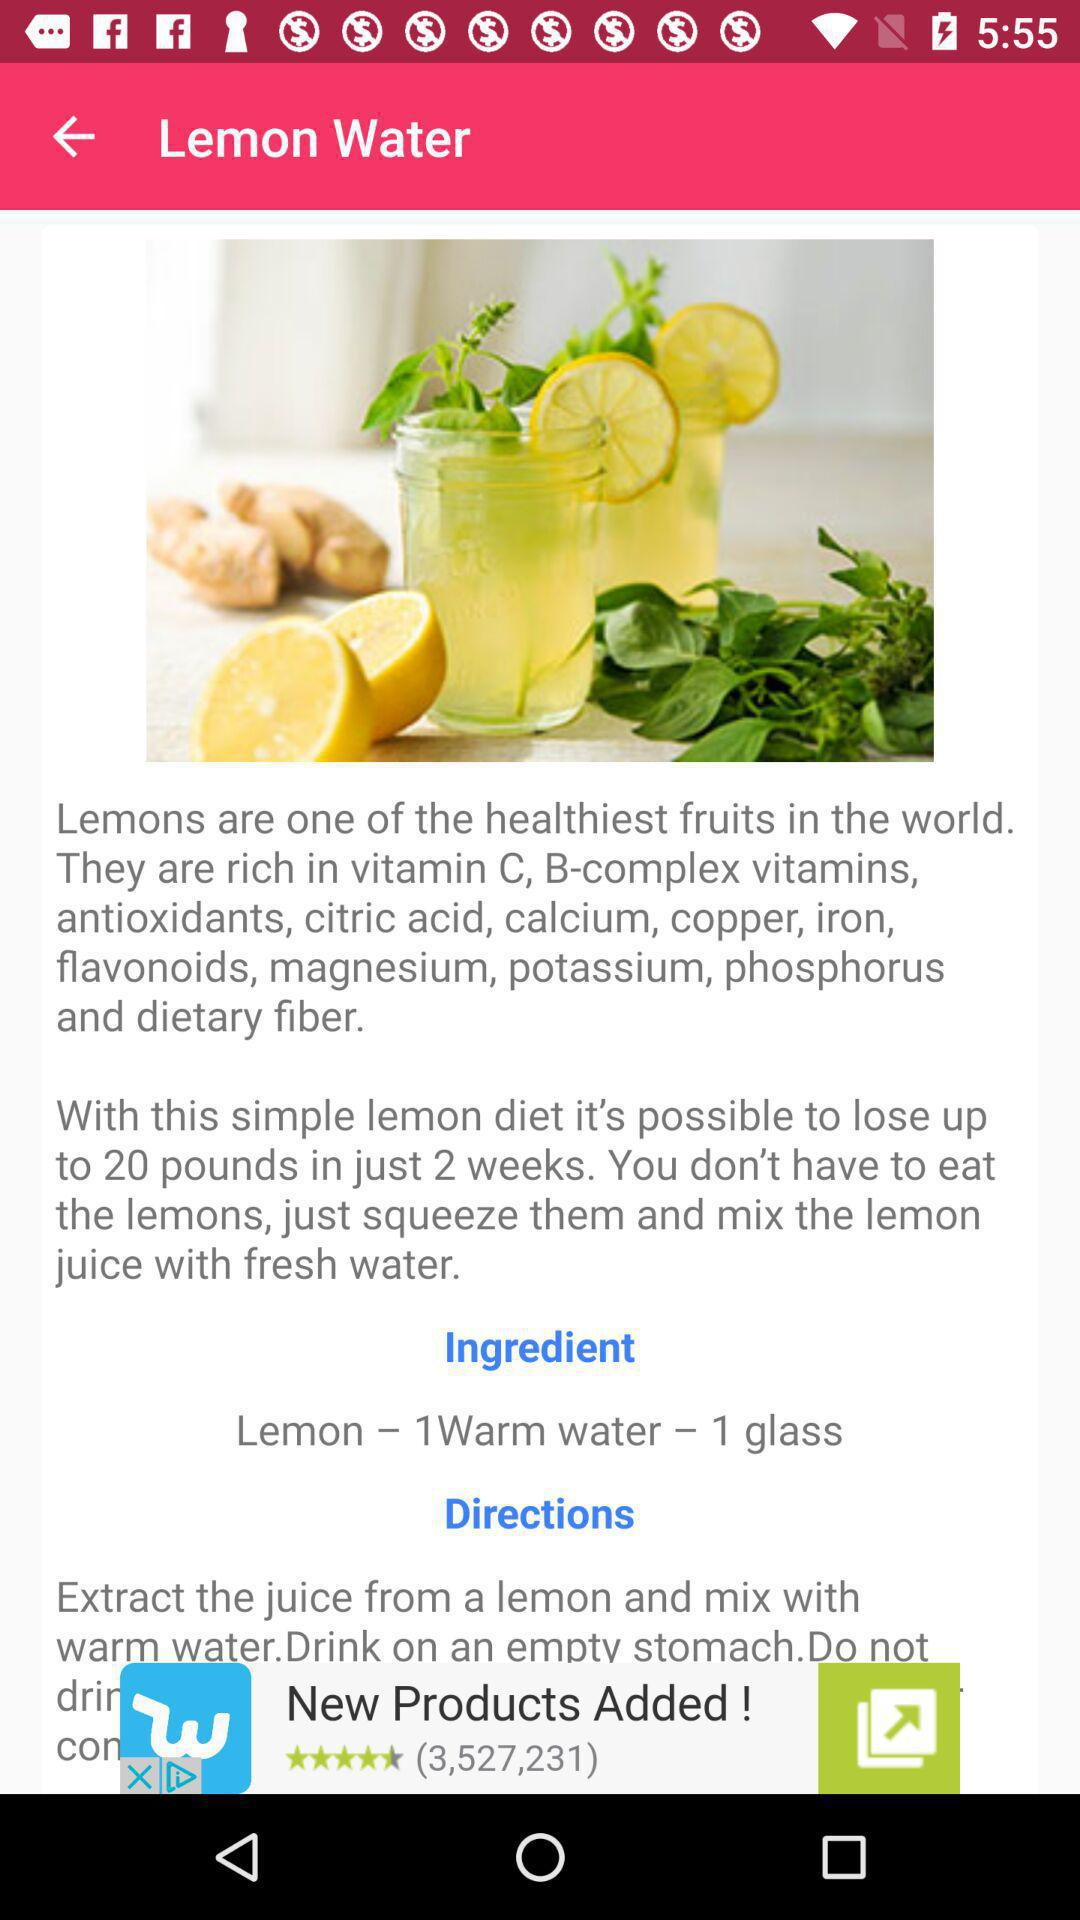What are the ingredients required for lemon water? The ingredients are "Lemon - 1Warm water - 1 glass". 